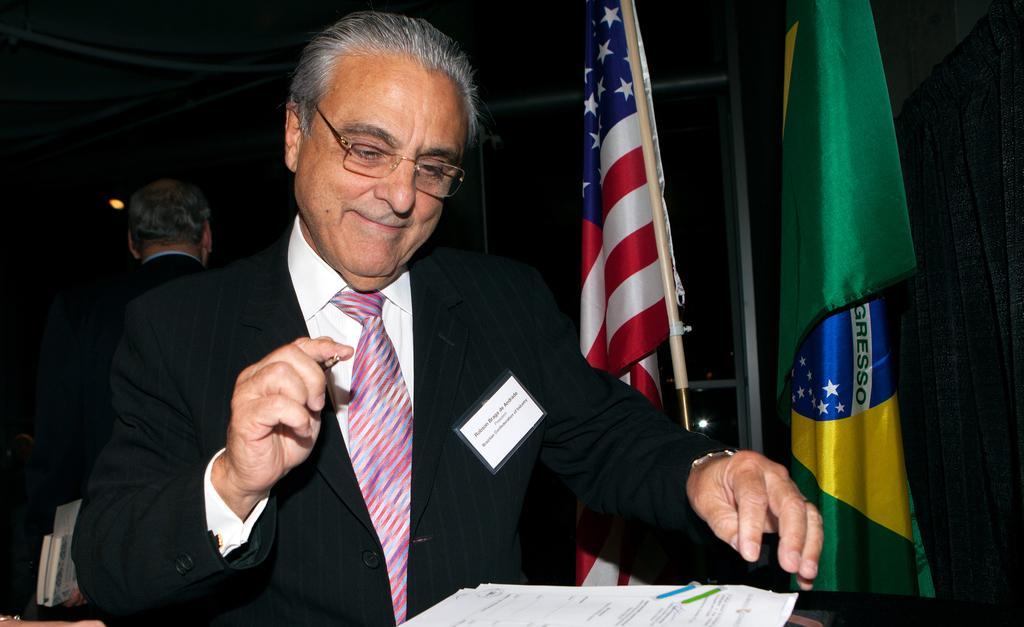Please provide a concise description of this image. There is a person holding a pen in the foreground area of the image, there are papers in front of him. There are flags and a man in the background. 